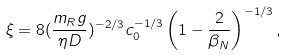Convert formula to latex. <formula><loc_0><loc_0><loc_500><loc_500>\xi = 8 ( \frac { m _ { R } g } { \eta D } ) ^ { - 2 / 3 } c _ { 0 } ^ { - 1 / 3 } \left ( 1 - \frac { 2 } { \beta _ { N } } \right ) ^ { - 1 / 3 } ,</formula> 